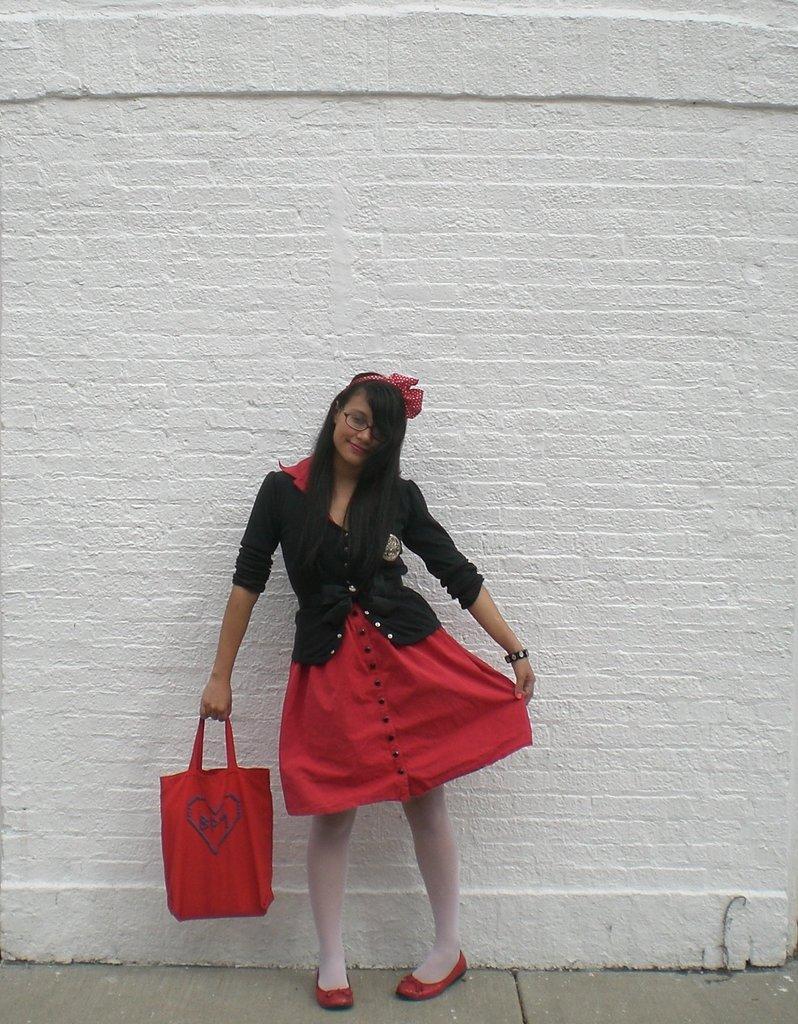Can you describe this image briefly? There is a lady wearing specs and hair band is holding a bag. In the back there is a brick wall. 